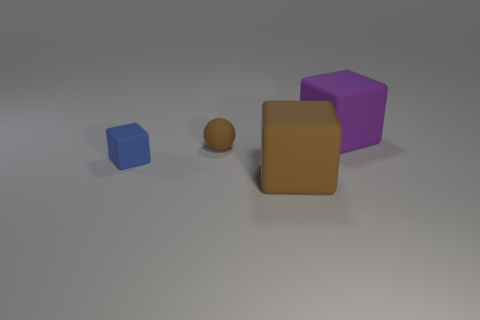Add 2 big red balls. How many objects exist? 6 Subtract all balls. How many objects are left? 3 Add 4 brown rubber things. How many brown rubber things are left? 6 Add 3 tiny blue shiny cylinders. How many tiny blue shiny cylinders exist? 3 Subtract 0 purple cylinders. How many objects are left? 4 Subtract all tiny brown rubber spheres. Subtract all big gray matte cylinders. How many objects are left? 3 